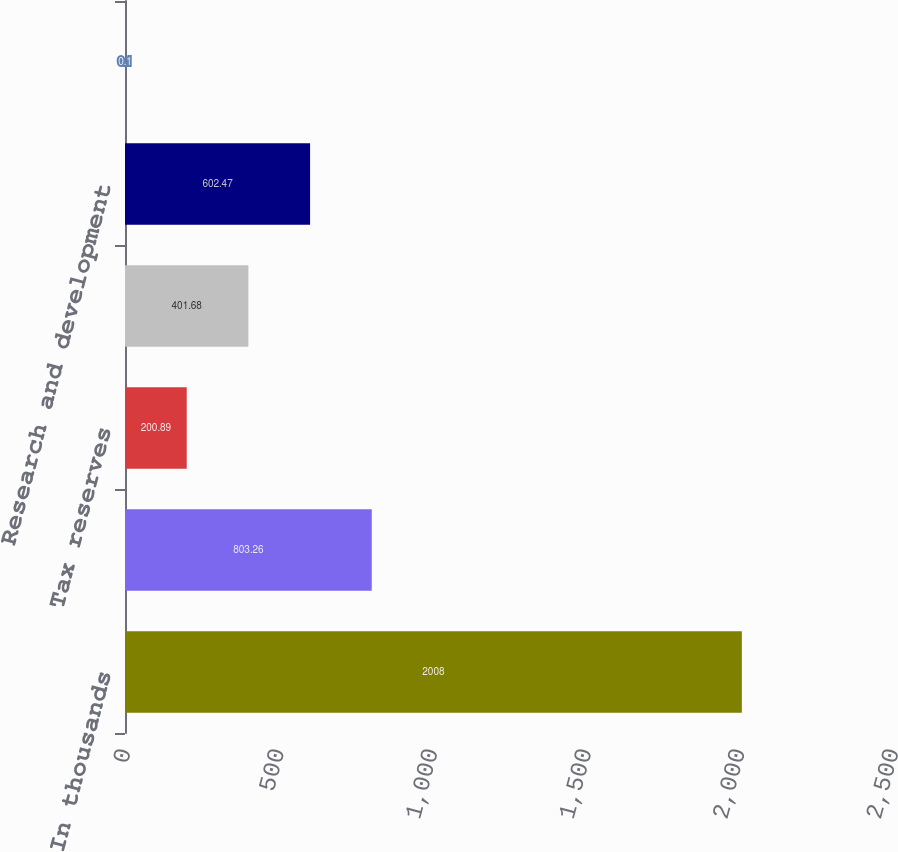<chart> <loc_0><loc_0><loc_500><loc_500><bar_chart><fcel>In thousands<fcel>State taxes<fcel>Tax reserves<fcel>Foreign<fcel>Research and development<fcel>Other net<nl><fcel>2008<fcel>803.26<fcel>200.89<fcel>401.68<fcel>602.47<fcel>0.1<nl></chart> 